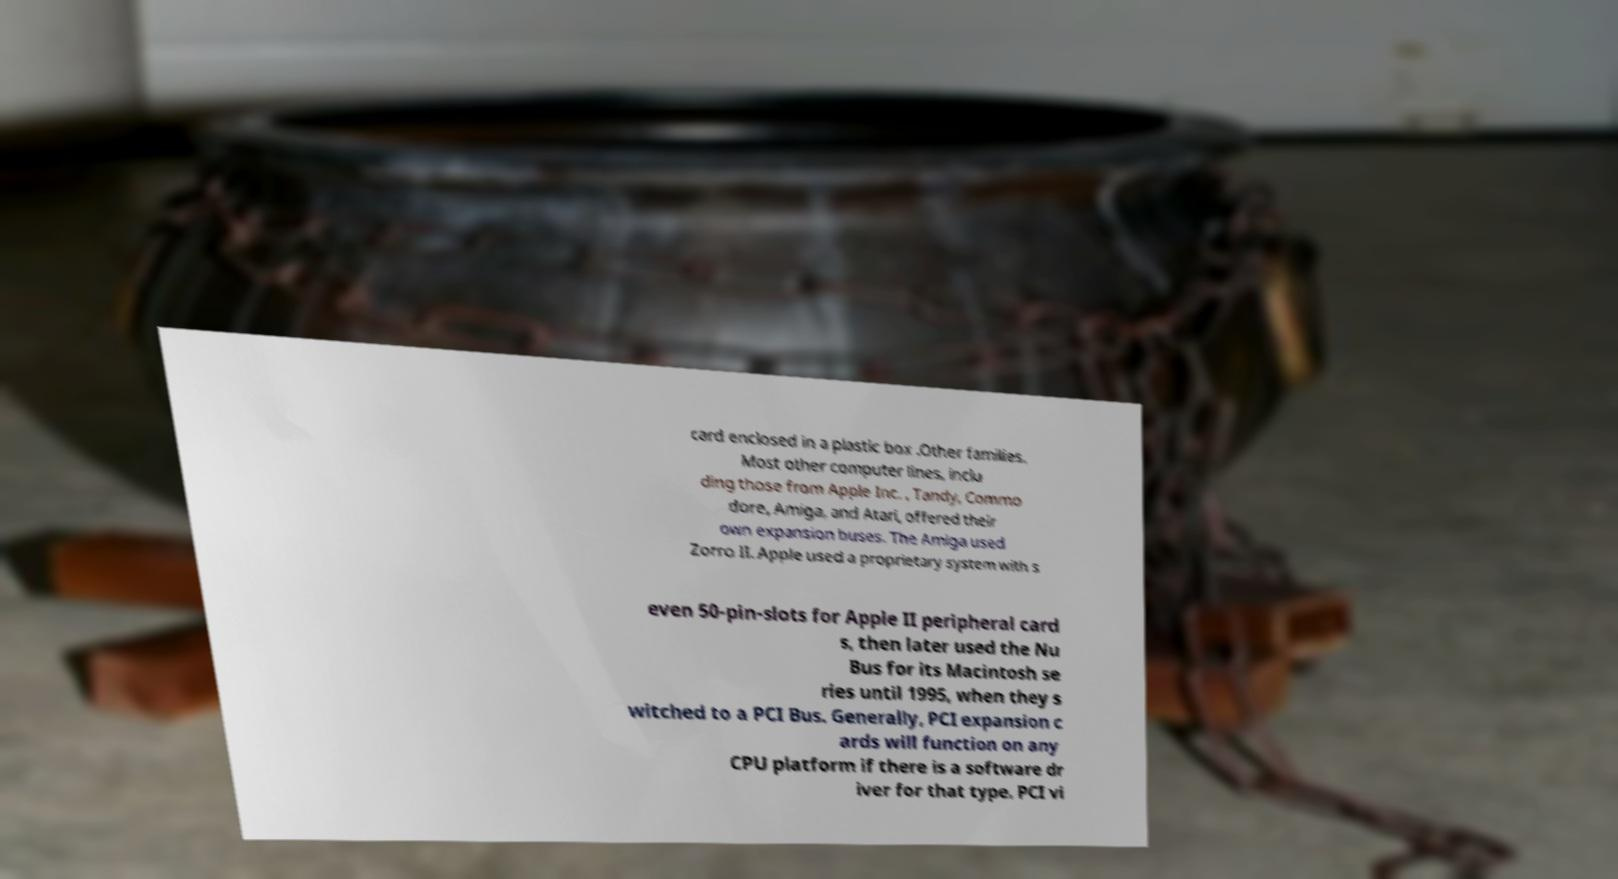There's text embedded in this image that I need extracted. Can you transcribe it verbatim? card enclosed in a plastic box .Other families. Most other computer lines, inclu ding those from Apple Inc. , Tandy, Commo dore, Amiga, and Atari, offered their own expansion buses. The Amiga used Zorro II. Apple used a proprietary system with s even 50-pin-slots for Apple II peripheral card s, then later used the Nu Bus for its Macintosh se ries until 1995, when they s witched to a PCI Bus. Generally, PCI expansion c ards will function on any CPU platform if there is a software dr iver for that type. PCI vi 